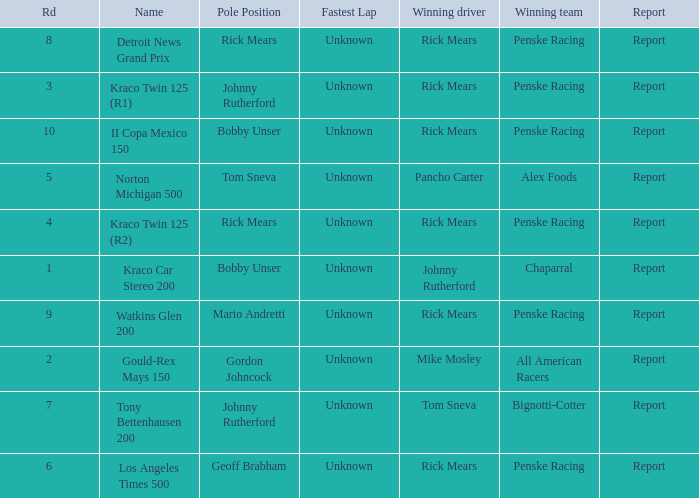What are the races that johnny rutherford has won? Kraco Car Stereo 200. 